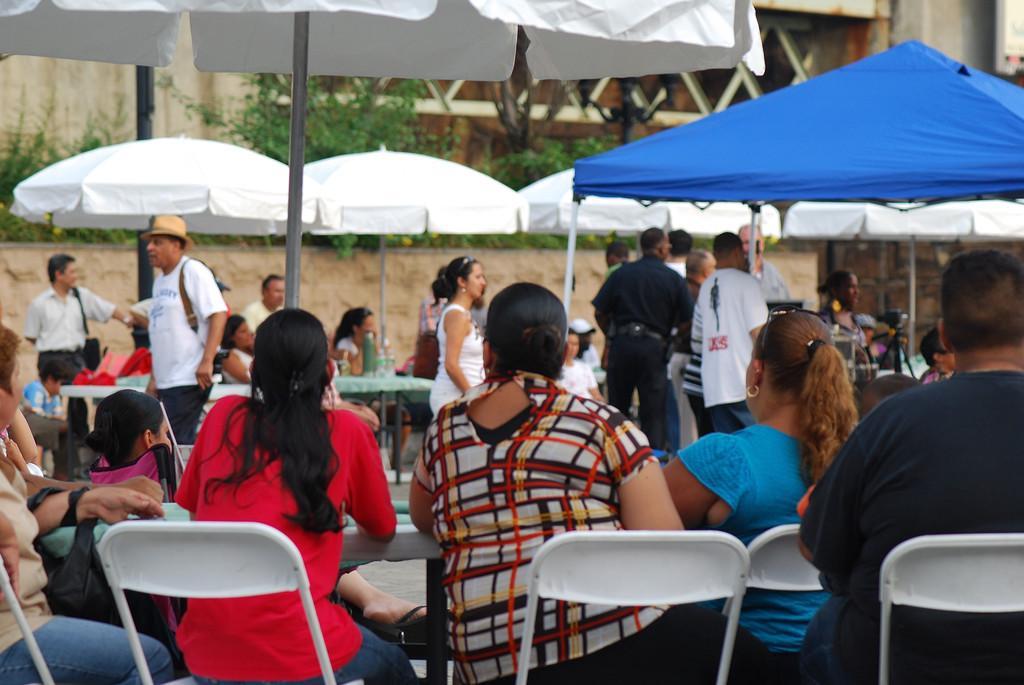In one or two sentences, can you explain what this image depicts? Here in this picture we can see front three ladies are sitting in the chair. And some people are standing. We can see a blue tent and a white tent. There are some trees. There is a building in the background. 